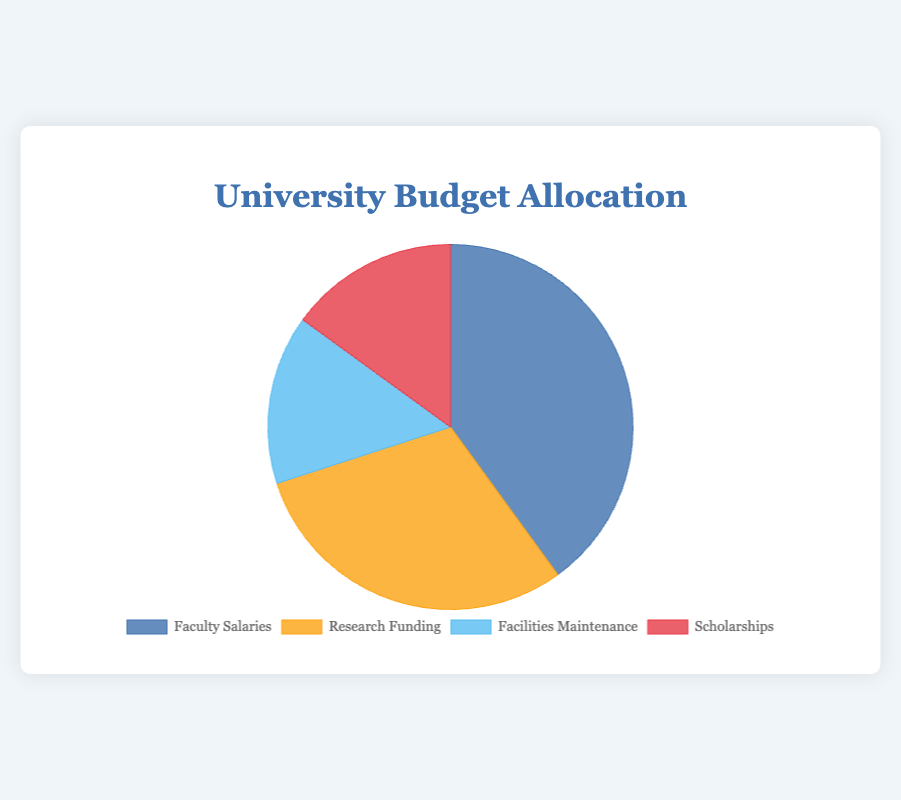Which category receives the highest percentage of the budget? By looking at the pie chart, the largest slice represents the category with the highest percentage. The largest slice corresponds to Faculty Salaries.
Answer: Faculty Salaries What is the combined percentage of the budget allocated to Scholarships and Facilities Maintenance? Summing the percentages for Scholarships (15%) and Facilities Maintenance (15%) gives 15% + 15% = 30%.
Answer: 30% How much more of the budget is allocated to Faculty Salaries compared to Research Funding? Comparing the percentages, Faculty Salaries has 40%, and Research Funding has 30%, so the difference is 40% - 30% = 10%.
Answer: 10% Which two categories together use up the same amount of budget as Faculty Salaries alone? Faculty Salaries have 40%. Looking for two categories that sum up to this, Research Funding (30%) and Facilities Maintenance (15%) together total 30% + 15% = 45%, which is more. However, Facilities Maintenance (15%) and Scholarships (15%) together total 15% + 15% = 30%, which is less. Research Funding (30%) and Scholarships (15%) together total 30% + 15% = 45%, which exceeds 40%. After rechecking combinations, there isn't a pair that aligns.
Answer: None What percentage of the budget is allocated to categories other than Research Funding? Subtracting Research Funding's percentage (30%) from the total budget (100%) gives 100% - 30% = 70%.
Answer: 70% How does the proportion of the budget for Facilities Maintenance compare with that for Scholarships? The pie chart shows both categories are allocated 15%, meaning they receive equal proportions of the budget.
Answer: Equal If the slice representing Faculty Salaries is blue, how can you visually differentiate the slice for Research Funding? The pie chart's legend usually helps in identifying colors. If Faculty Salaries are blue, check the slice with the second largest portion, it's likely a different color, such as orange.
Answer: Different color (likely orange) Of the total budget, what fraction does Faculty Salaries consume relative to Scholarships? Faculty Salaries take up 40% while Scholarships take up 15%. The fraction is 40% / 15%, which simplifies to approximately 2.67.
Answer: 2.67 What would be the average percentage for each category if the budget was evenly distributed across all four categories? Dividing the total budget (100%) by the number of categories (4) yields 100% / 4 = 25%.
Answer: 25% 